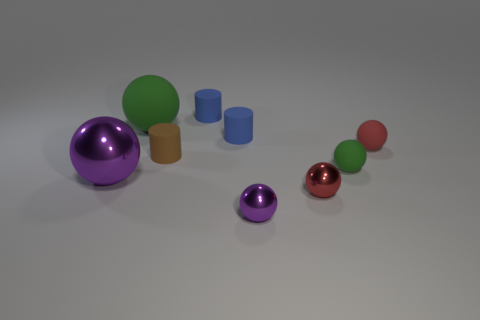Subtract all small brown cylinders. How many cylinders are left? 2 Add 1 small purple metallic things. How many objects exist? 10 Subtract all brown cylinders. How many cylinders are left? 2 Subtract all yellow cylinders. How many red balls are left? 2 Subtract all brown balls. Subtract all purple blocks. How many balls are left? 6 Subtract all small rubber objects. Subtract all red metal spheres. How many objects are left? 3 Add 1 small objects. How many small objects are left? 8 Add 1 small purple metal objects. How many small purple metal objects exist? 2 Subtract 0 blue blocks. How many objects are left? 9 Subtract all cylinders. How many objects are left? 6 